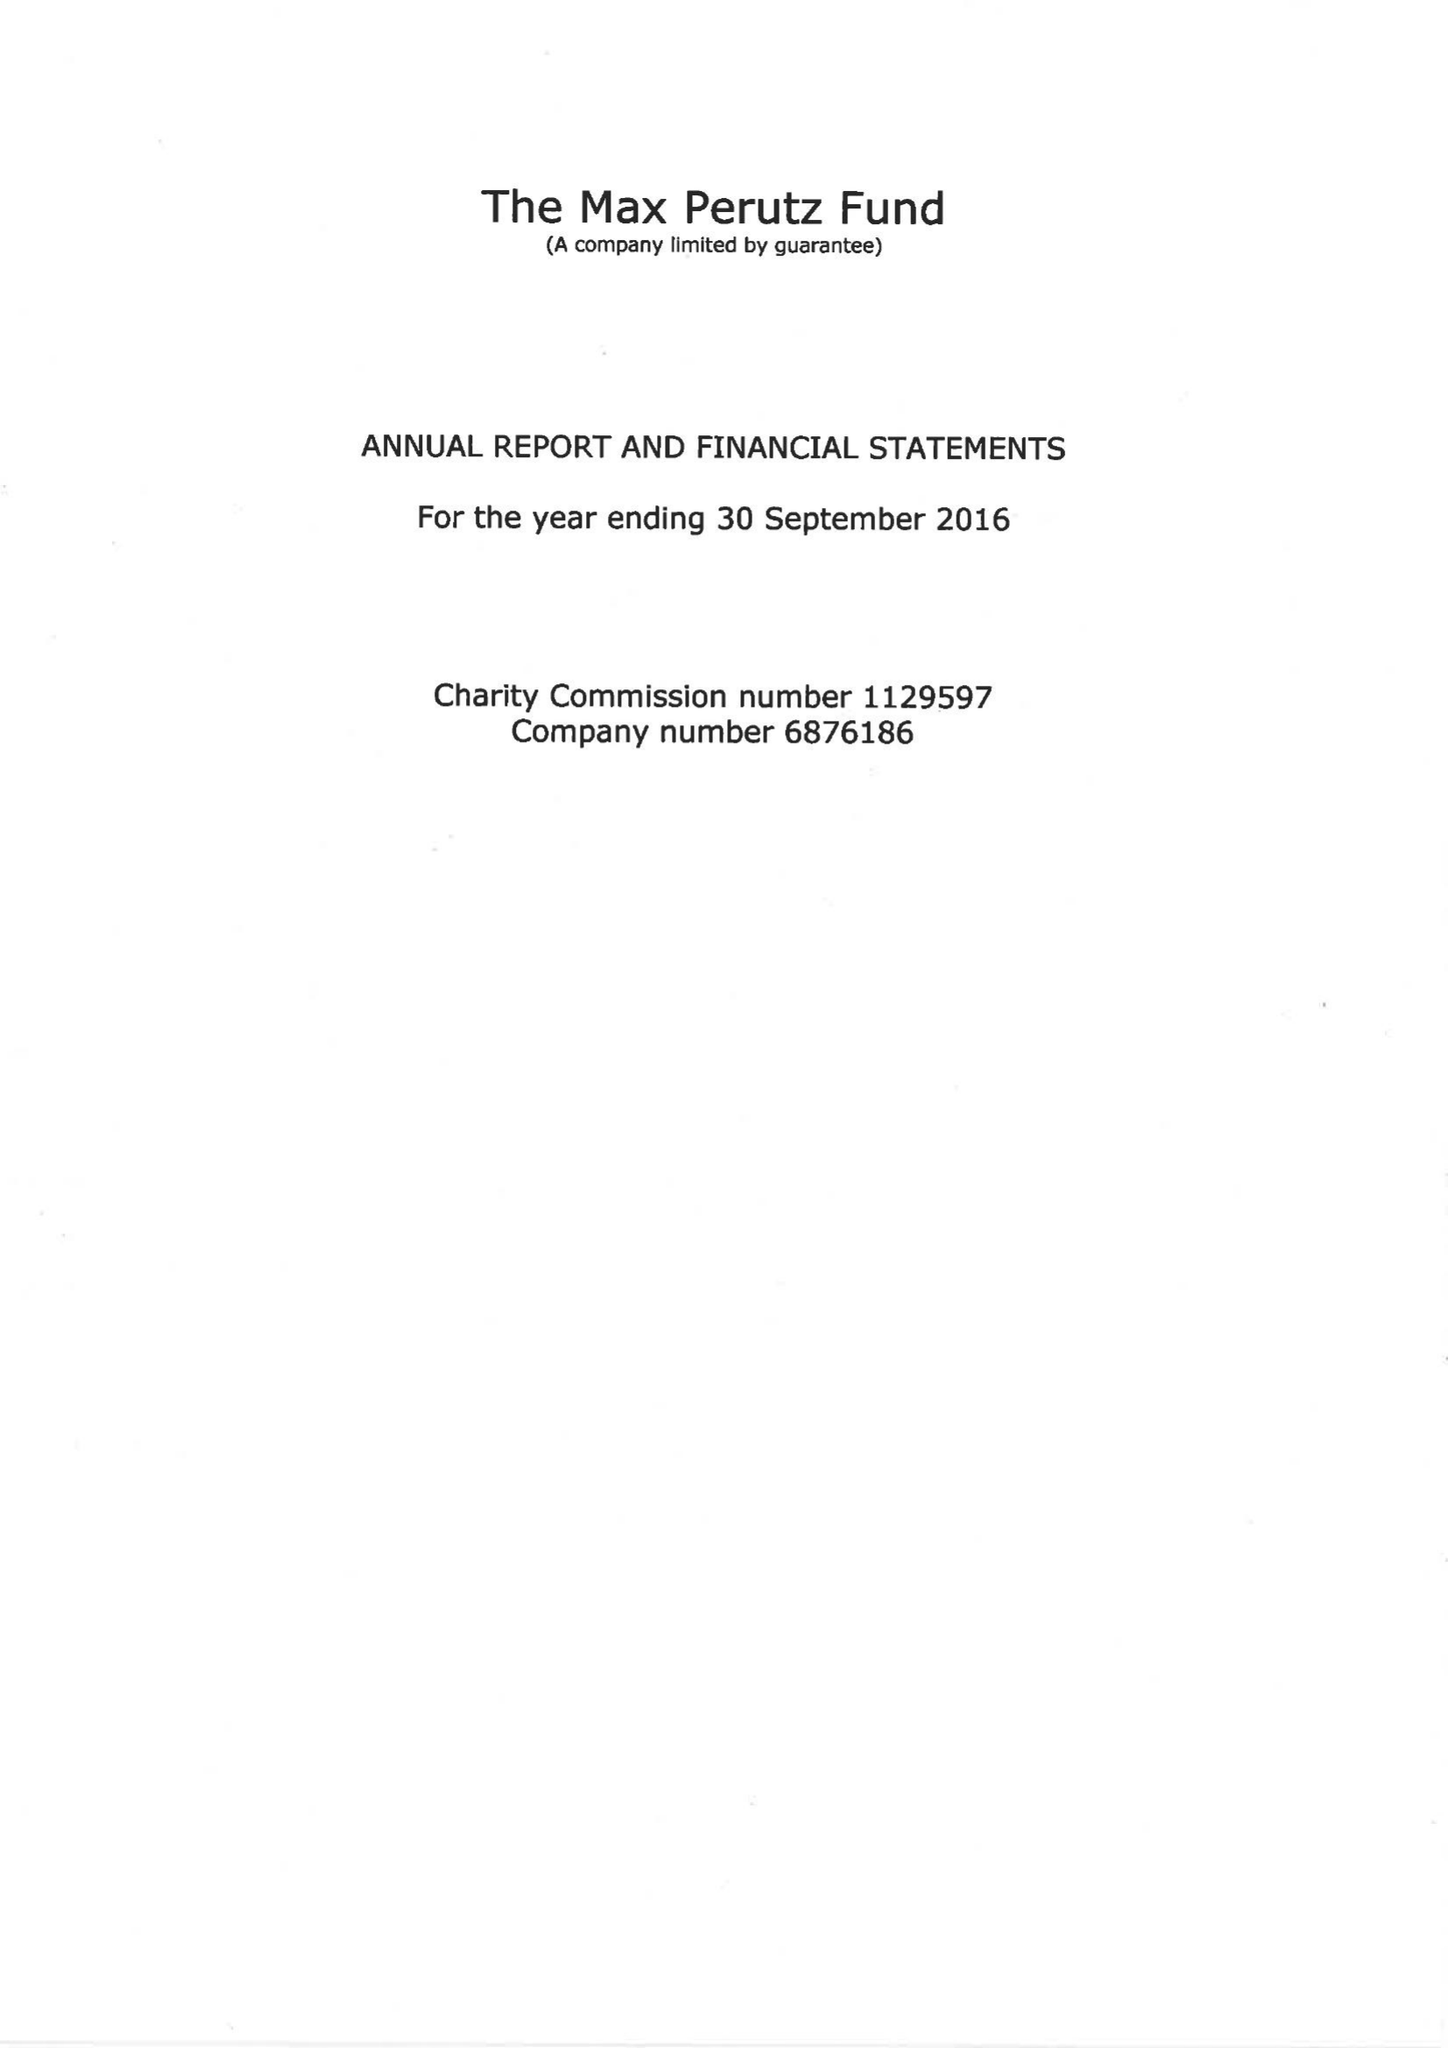What is the value for the charity_name?
Answer the question using a single word or phrase. The Max Perutz Fund 